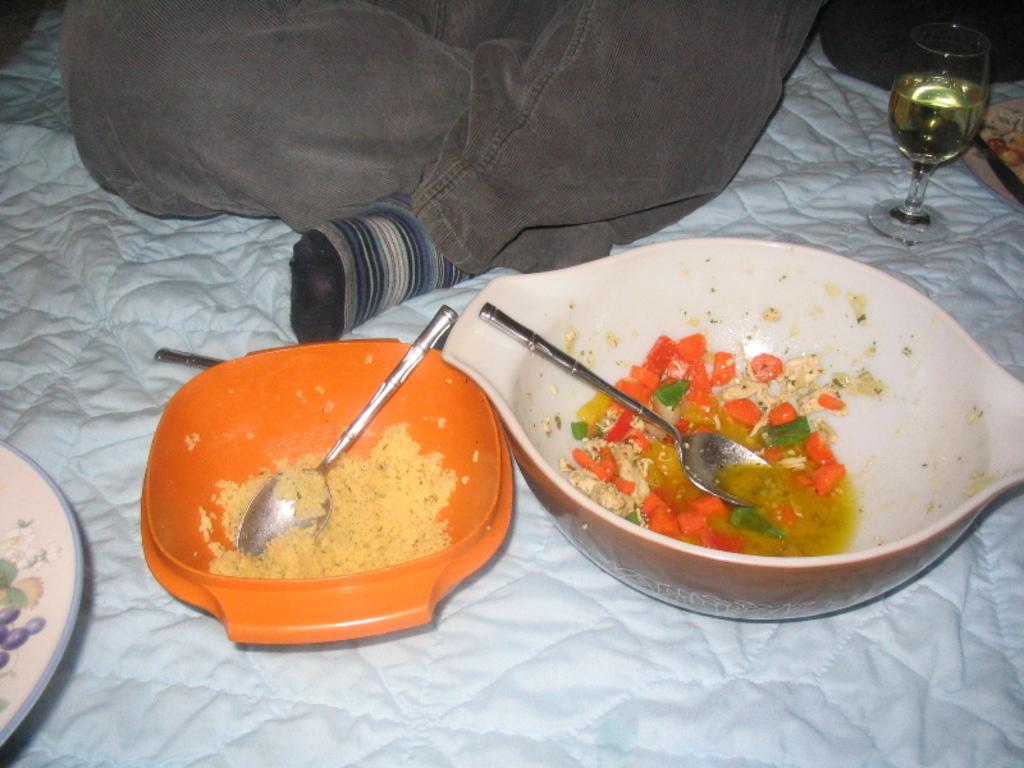What is in the bowl that is visible in the image? There is a bowl with food items in the image. What utensils are present in the image? There are spoons in the image. What is the bowl placed on? The bowl is placed on a cloth. What type of clothing item is visible in the image? There is a coat visible in the image. What is in the glass that is visible in the image? There is a glass with liquid in the image. What type of advertisement can be seen on the root in the image? There is no advertisement or root present in the image. 